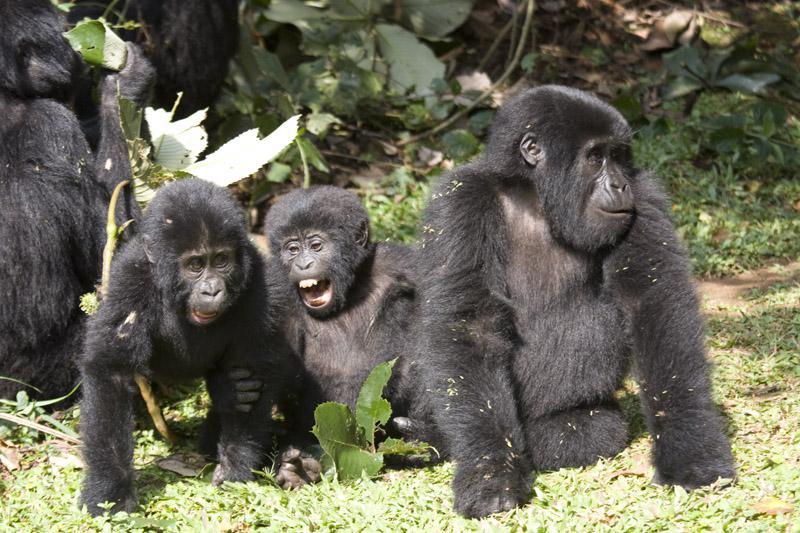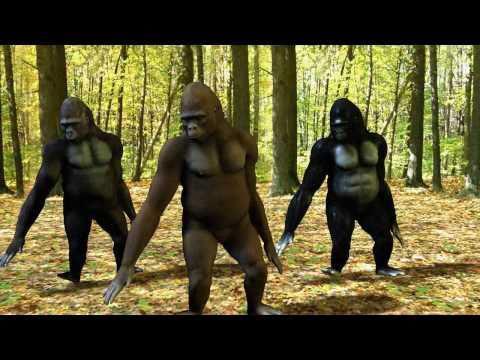The first image is the image on the left, the second image is the image on the right. Considering the images on both sides, is "The left and right image contains the same number of real breathing gorillas." valid? Answer yes or no. No. The first image is the image on the left, the second image is the image on the right. Considering the images on both sides, is "There are six gorillas tht are sitting" valid? Answer yes or no. No. 